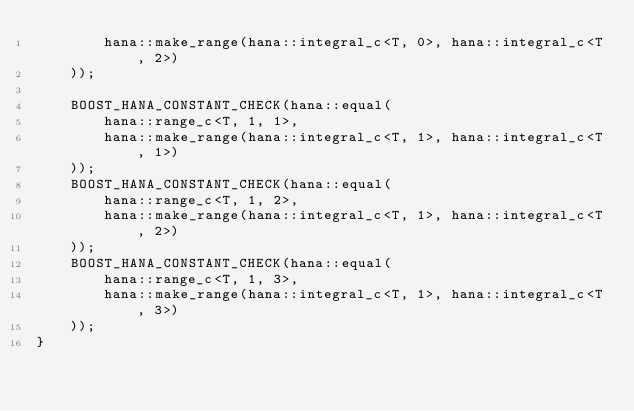<code> <loc_0><loc_0><loc_500><loc_500><_C++_>        hana::make_range(hana::integral_c<T, 0>, hana::integral_c<T, 2>)
    ));

    BOOST_HANA_CONSTANT_CHECK(hana::equal(
        hana::range_c<T, 1, 1>,
        hana::make_range(hana::integral_c<T, 1>, hana::integral_c<T, 1>)
    ));
    BOOST_HANA_CONSTANT_CHECK(hana::equal(
        hana::range_c<T, 1, 2>,
        hana::make_range(hana::integral_c<T, 1>, hana::integral_c<T, 2>)
    ));
    BOOST_HANA_CONSTANT_CHECK(hana::equal(
        hana::range_c<T, 1, 3>,
        hana::make_range(hana::integral_c<T, 1>, hana::integral_c<T, 3>)
    ));
}
</code> 